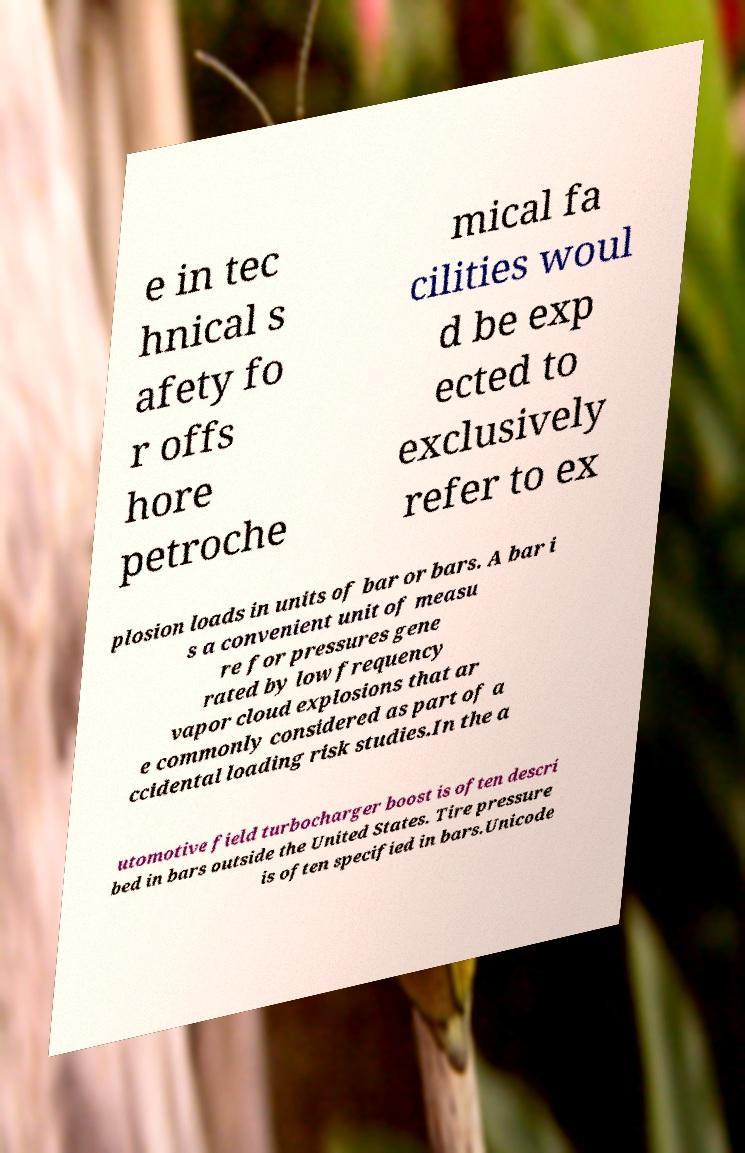For documentation purposes, I need the text within this image transcribed. Could you provide that? e in tec hnical s afety fo r offs hore petroche mical fa cilities woul d be exp ected to exclusively refer to ex plosion loads in units of bar or bars. A bar i s a convenient unit of measu re for pressures gene rated by low frequency vapor cloud explosions that ar e commonly considered as part of a ccidental loading risk studies.In the a utomotive field turbocharger boost is often descri bed in bars outside the United States. Tire pressure is often specified in bars.Unicode 